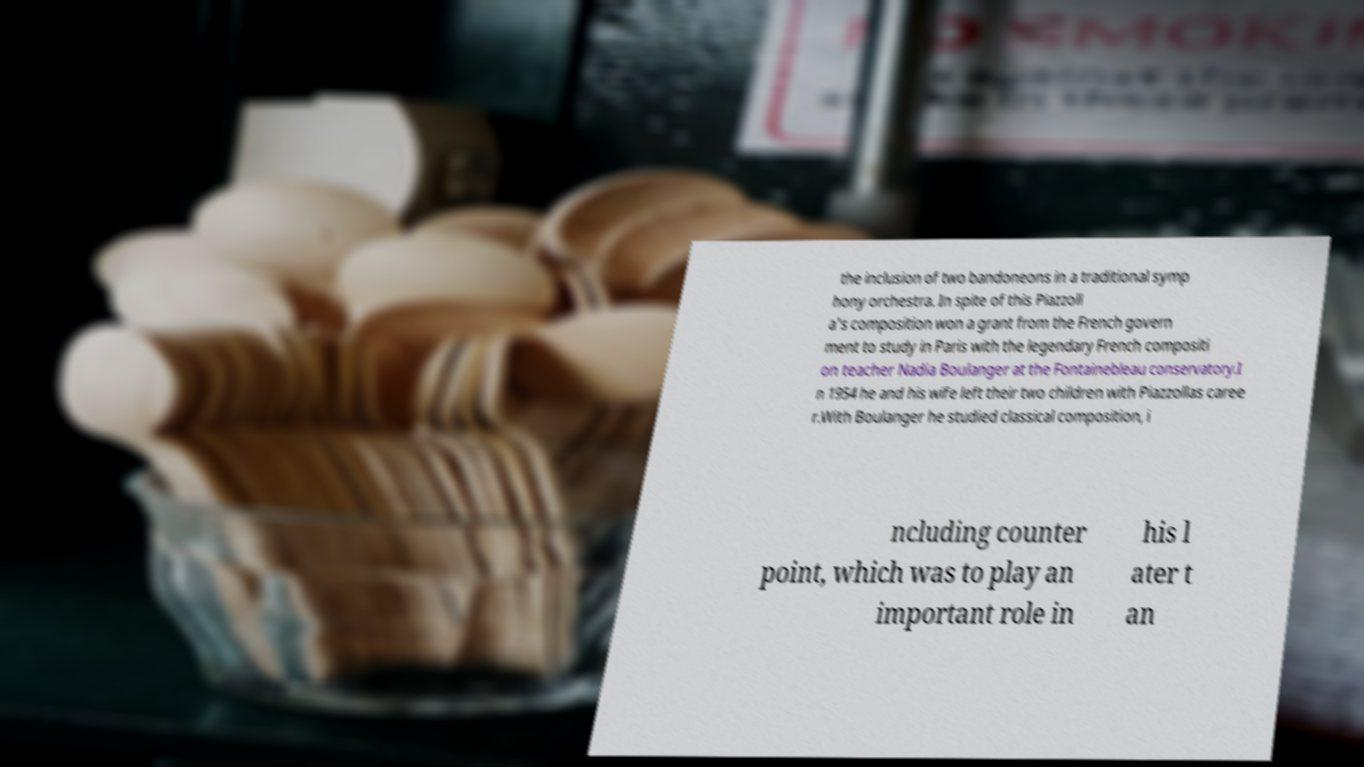I need the written content from this picture converted into text. Can you do that? the inclusion of two bandoneons in a traditional symp hony orchestra. In spite of this Piazzoll a's composition won a grant from the French govern ment to study in Paris with the legendary French compositi on teacher Nadia Boulanger at the Fontainebleau conservatory.I n 1954 he and his wife left their two children with Piazzollas caree r.With Boulanger he studied classical composition, i ncluding counter point, which was to play an important role in his l ater t an 